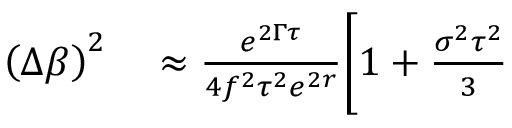<formula> <loc_0><loc_0><loc_500><loc_500>\begin{array} { r l } { \left ( \Delta \beta \right ) ^ { 2 } } & \approx \frac { e ^ { 2 \Gamma \tau } } { 4 f ^ { 2 } \tau ^ { 2 } e ^ { 2 r } } \Big [ 1 + \frac { \sigma ^ { 2 } \tau ^ { 2 } } { 3 } } \end{array}</formula> 